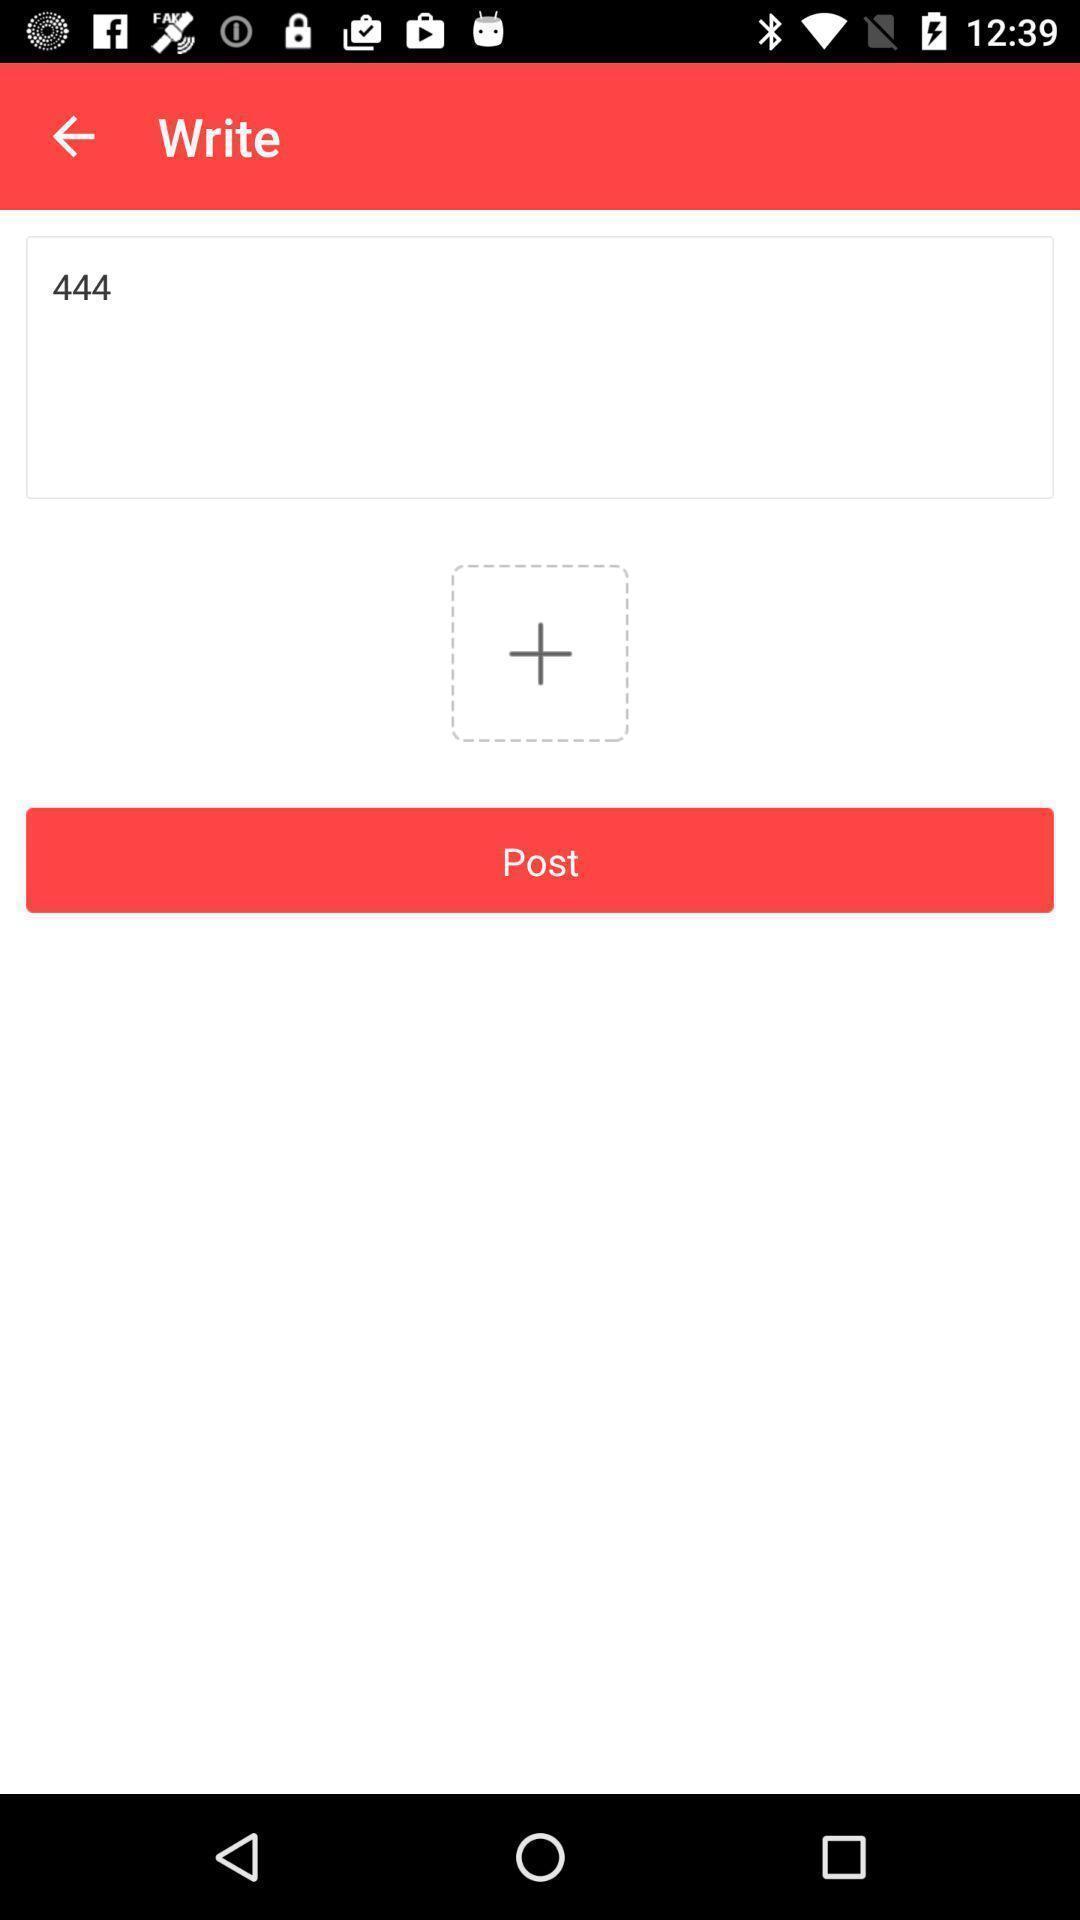Please provide a description for this image. Screen shows to write a post. 